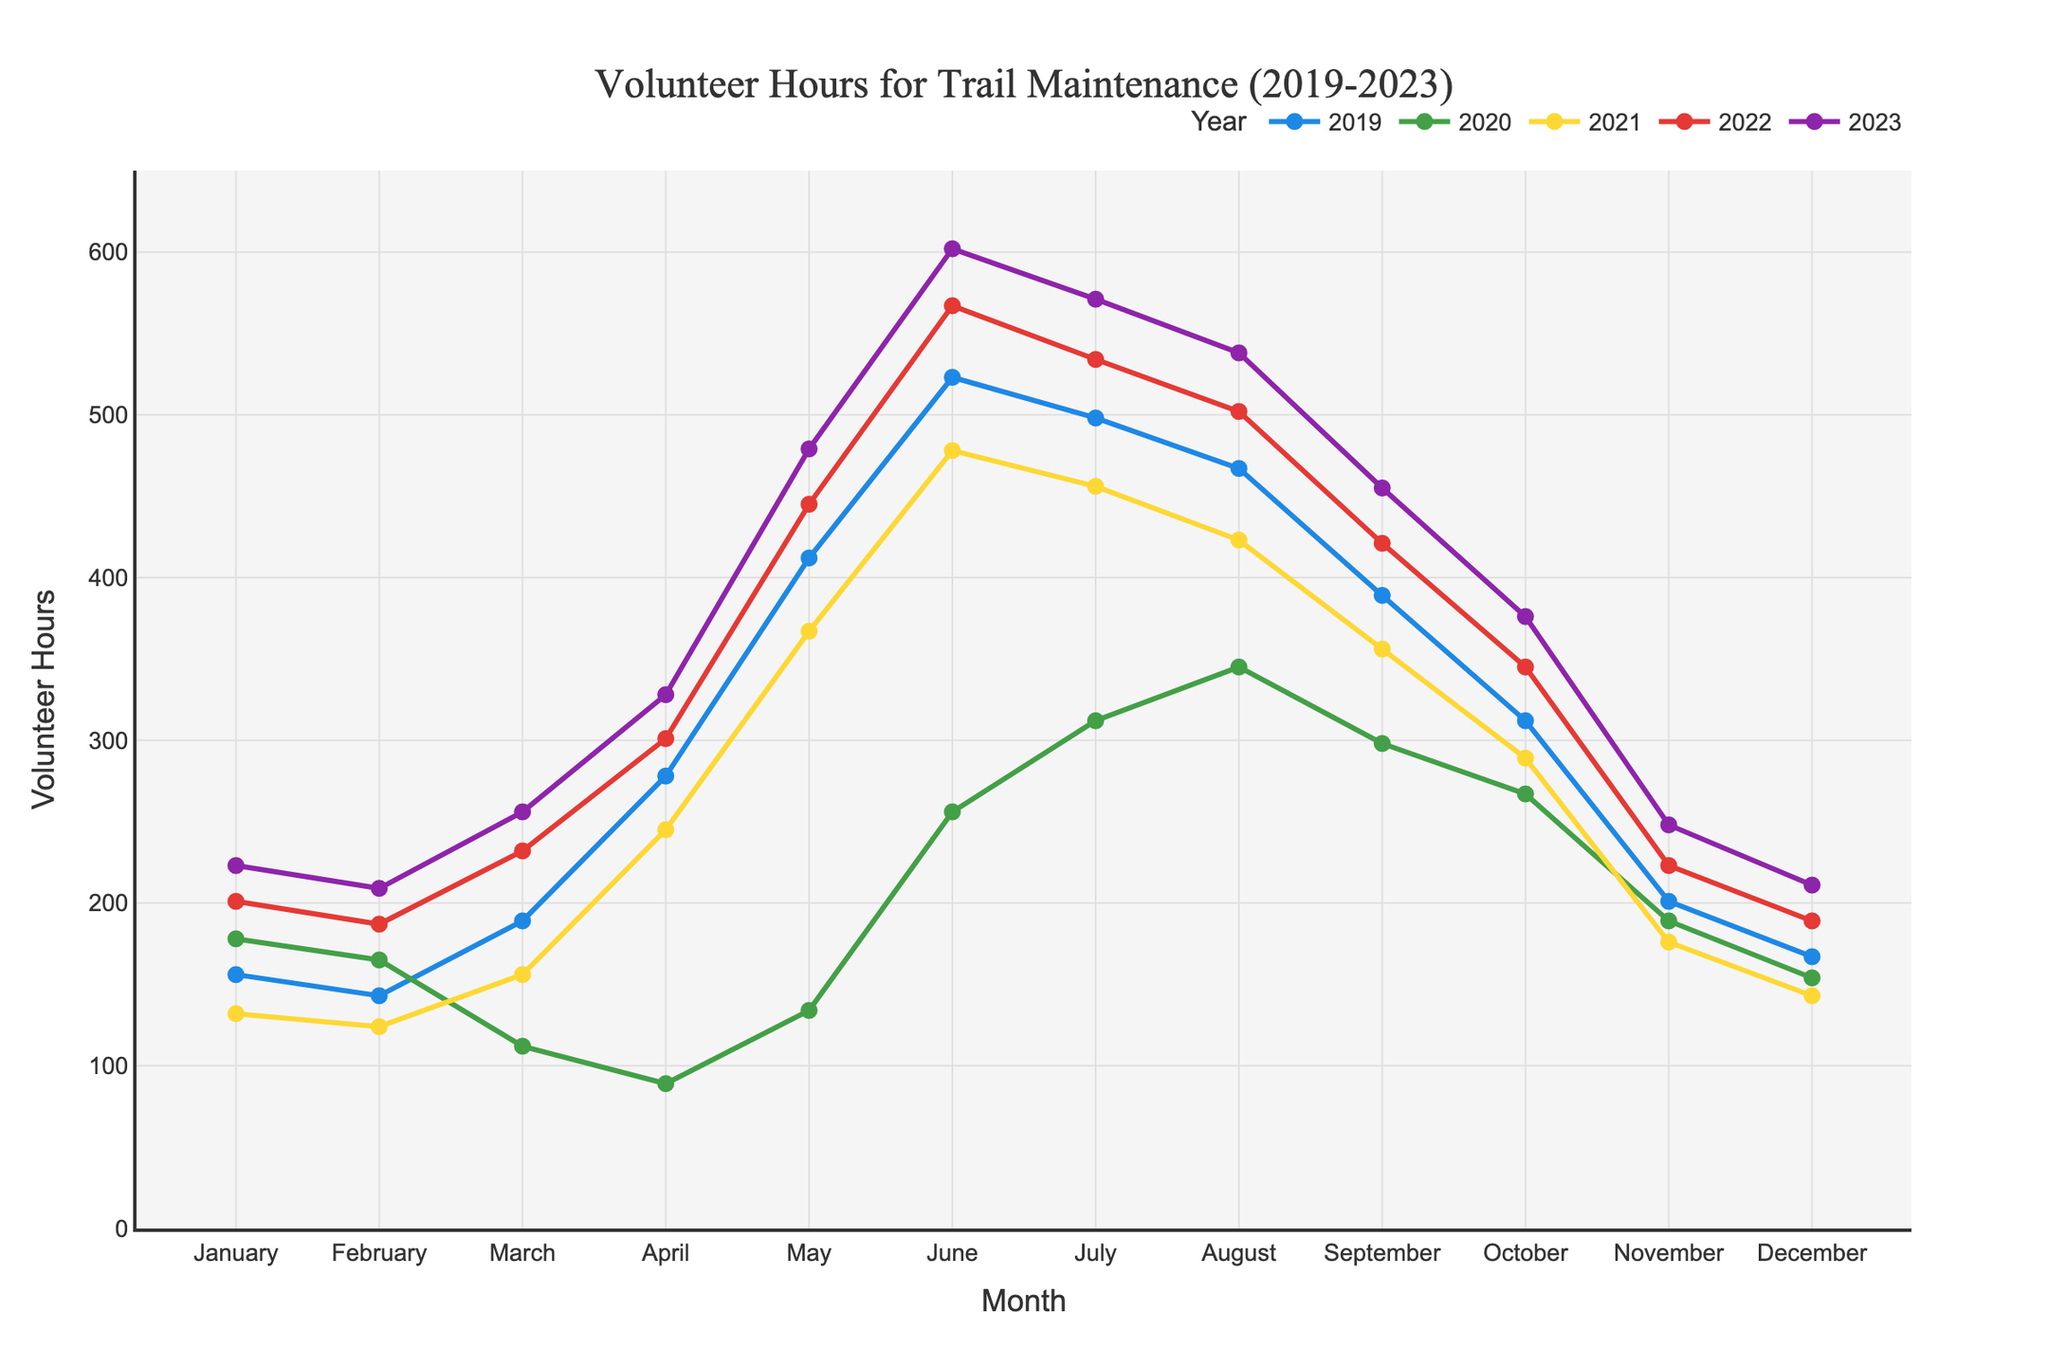What month in 2023 had the highest volunteer hours? The highest point on the line for 2023 represents the peak volunteer hours for that year. By observing the chart, the month corresponding to this peak value is May.
Answer: May Which year had the lowest volunteer hours in April? Look at the data points for April across all years. The lowest point is for the year 2020.
Answer: 2020 How many total volunteer hours were contributed in July across all years? Sum the volunteer hours for July from all years: 498 (2019) + 312 (2020) + 456 (2021) + 534 (2022) + 571 (2023) = 2371.
Answer: 2371 January: 201 - 178
Answer: = 23 February: 187 - 165
Answer: = 22 March: 232 - 112
Answer: = 120 April: 301 - 89
Answer: = 212 May: 445 - 134
Answer: = 311 June: 567 - 256
Answer: = 311 July: 534 - 312
Answer: = 222 August: 502 - 345
Answer: = 157 September: 421 - 298
Answer: = 123 October: 345 - 267
Answer: = 78 November: 223 - 189
Answer: = 34 December: 189 - 154
Answer: = 35 